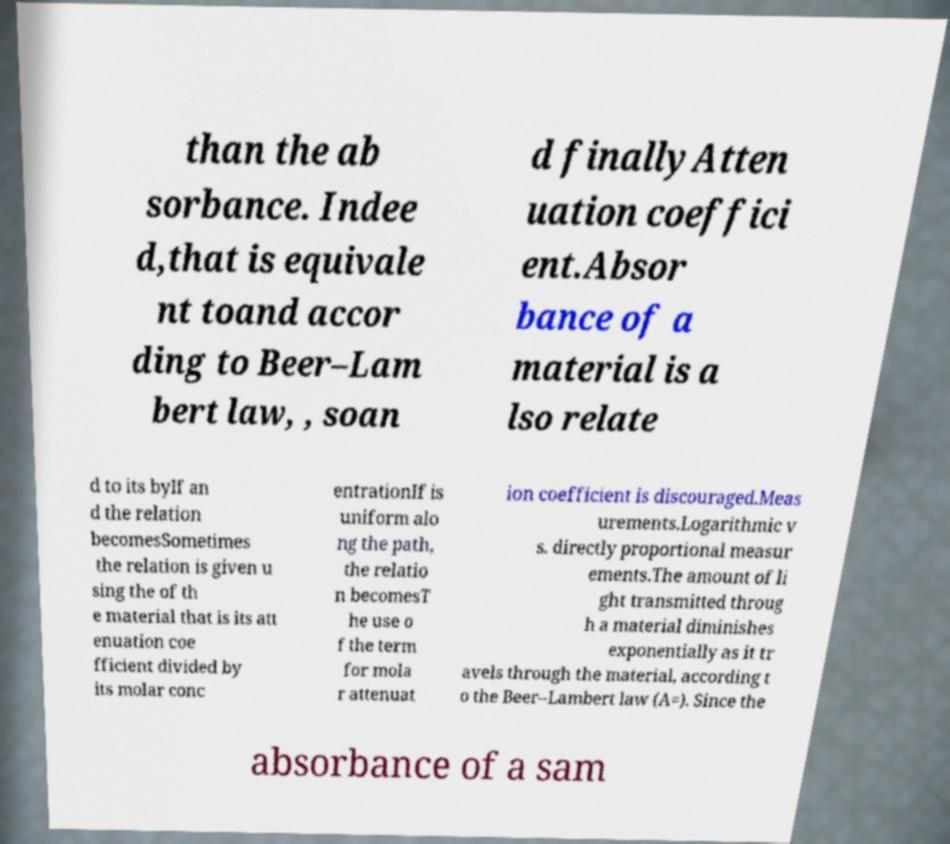Could you extract and type out the text from this image? than the ab sorbance. Indee d,that is equivale nt toand accor ding to Beer–Lam bert law, , soan d finallyAtten uation coeffici ent.Absor bance of a material is a lso relate d to its byIf an d the relation becomesSometimes the relation is given u sing the of th e material that is its att enuation coe fficient divided by its molar conc entrationIf is uniform alo ng the path, the relatio n becomesT he use o f the term for mola r attenuat ion coefficient is discouraged.Meas urements.Logarithmic v s. directly proportional measur ements.The amount of li ght transmitted throug h a material diminishes exponentially as it tr avels through the material, according t o the Beer–Lambert law (A=). Since the absorbance of a sam 